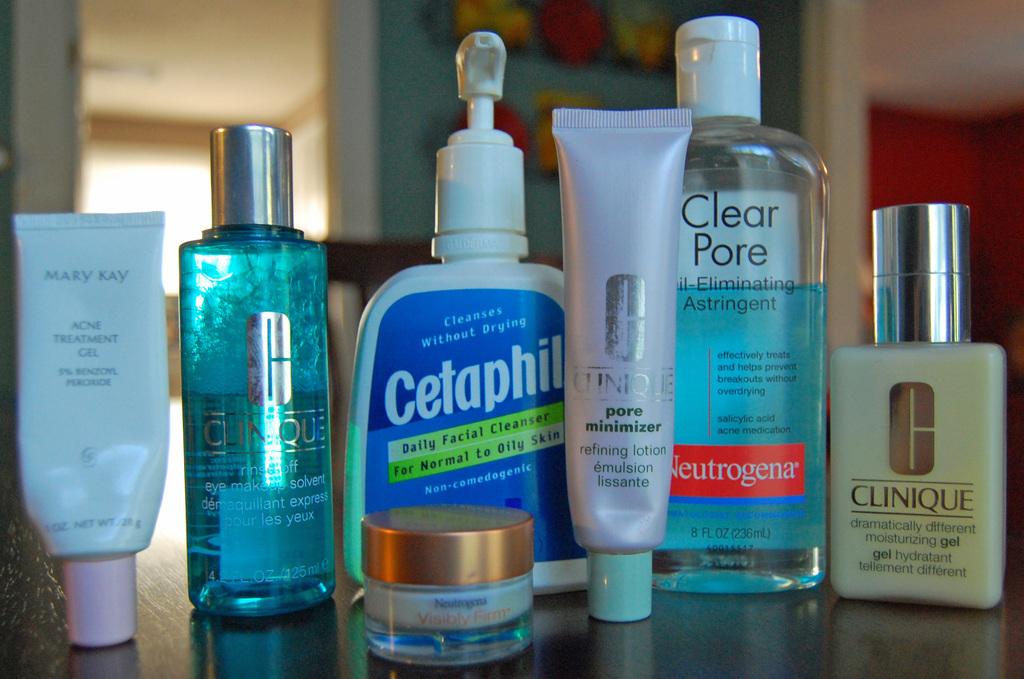What area of the body are most of these treatments for?
Give a very brief answer. Face. What brand is the acne treatment gel on the far left?
Offer a terse response. Mary kay. 